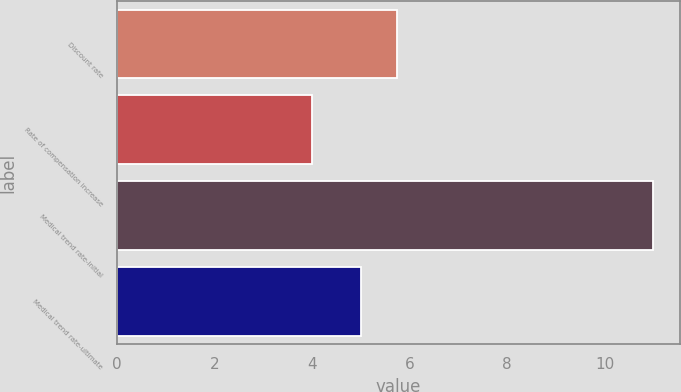<chart> <loc_0><loc_0><loc_500><loc_500><bar_chart><fcel>Discount rate<fcel>Rate of compensation increase<fcel>Medical trend rate-initial<fcel>Medical trend rate-ultimate<nl><fcel>5.75<fcel>4<fcel>11<fcel>5<nl></chart> 